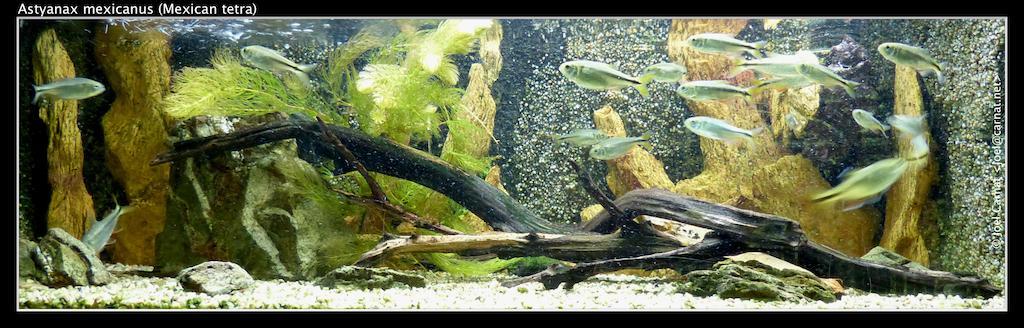How would you summarize this image in a sentence or two? In the picture I can see green color fishes are swimming in the water. Here I can see marine plants, stones, a few more objects in the water. Here I can see the watermark at the top left side of the image. 